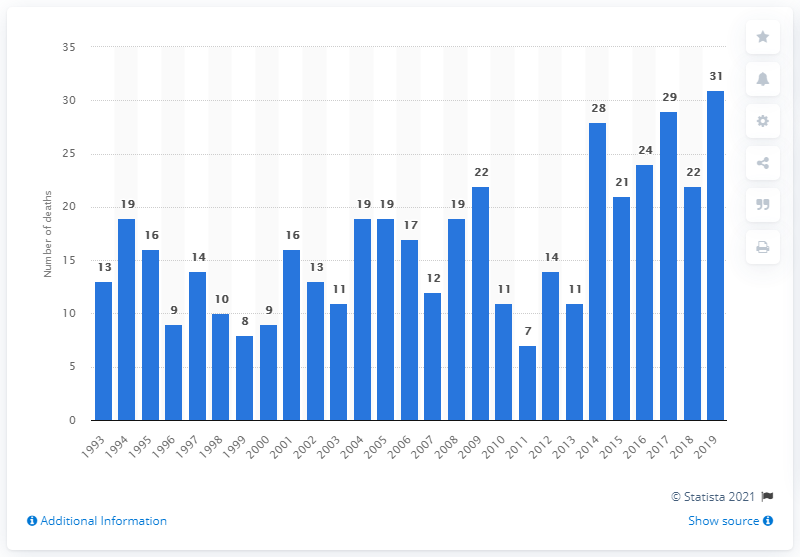List a handful of essential elements in this visual. The number of deaths related to cannabis use in England and Wales in 2019 was 31. In 2017, the number of cannabis-related deaths in England and Wales reached a record high of 29. In 2017, the number of deaths related to cannabis in England and Wales reached 29. 